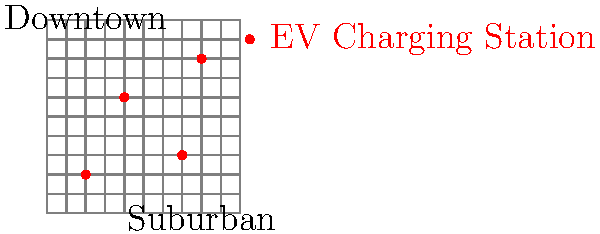As a senior policy advisor, you are analyzing the distribution of electric vehicle (EV) charging stations in a city to inform urban planning decisions. The map shows a 10x10 grid representing the city, with red dots indicating EV charging stations. Based on this distribution, which of the following statements is most accurate and relevant for developing climate change mitigation strategies?

A) The charging stations are evenly distributed across the city.
B) There is a higher concentration of charging stations in the downtown area.
C) The suburban areas are underserved by charging stations.
D) The current distribution is optimal for encouraging EV adoption. To answer this question, we need to analyze the distribution of EV charging stations on the map and consider its implications for climate change mitigation strategies. Let's break down the analysis step-by-step:

1. Observe the distribution:
   - There are 4 charging stations on the map.
   - Their coordinates are approximately (2,2), (4,6), (7,3), and (8,8).

2. Analyze the pattern:
   - The stations are not evenly distributed across the grid.
   - There is a slight clustering towards the center and upper-right of the map.

3. Consider the city layout:
   - The map labels indicate that the upper-left area is downtown, while the lower-right is suburban.

4. Evaluate the options:
   A) This is incorrect as the stations are clearly not evenly distributed.
   B) This is incorrect as there is only one station in the downtown area.
   C) This is correct. There is only one station in the labeled suburban area, which is likely insufficient for the population density.
   D) This is incorrect as the distribution does not appear optimal, especially given the lack of coverage in suburban areas.

5. Consider climate change mitigation implications:
   - Encouraging EV adoption is crucial for reducing transportation emissions.
   - Suburban areas often have higher car ownership rates and longer average trip distances.
   - Insufficient charging infrastructure in suburban areas could be a significant barrier to EV adoption.

Therefore, the most accurate and relevant statement for developing climate change mitigation strategies is option C: The suburban areas are underserved by charging stations.

This observation suggests that policymakers should focus on increasing charging infrastructure in suburban areas to encourage EV adoption and reduce emissions from transportation in these car-dependent regions.
Answer: C) The suburban areas are underserved by charging stations. 